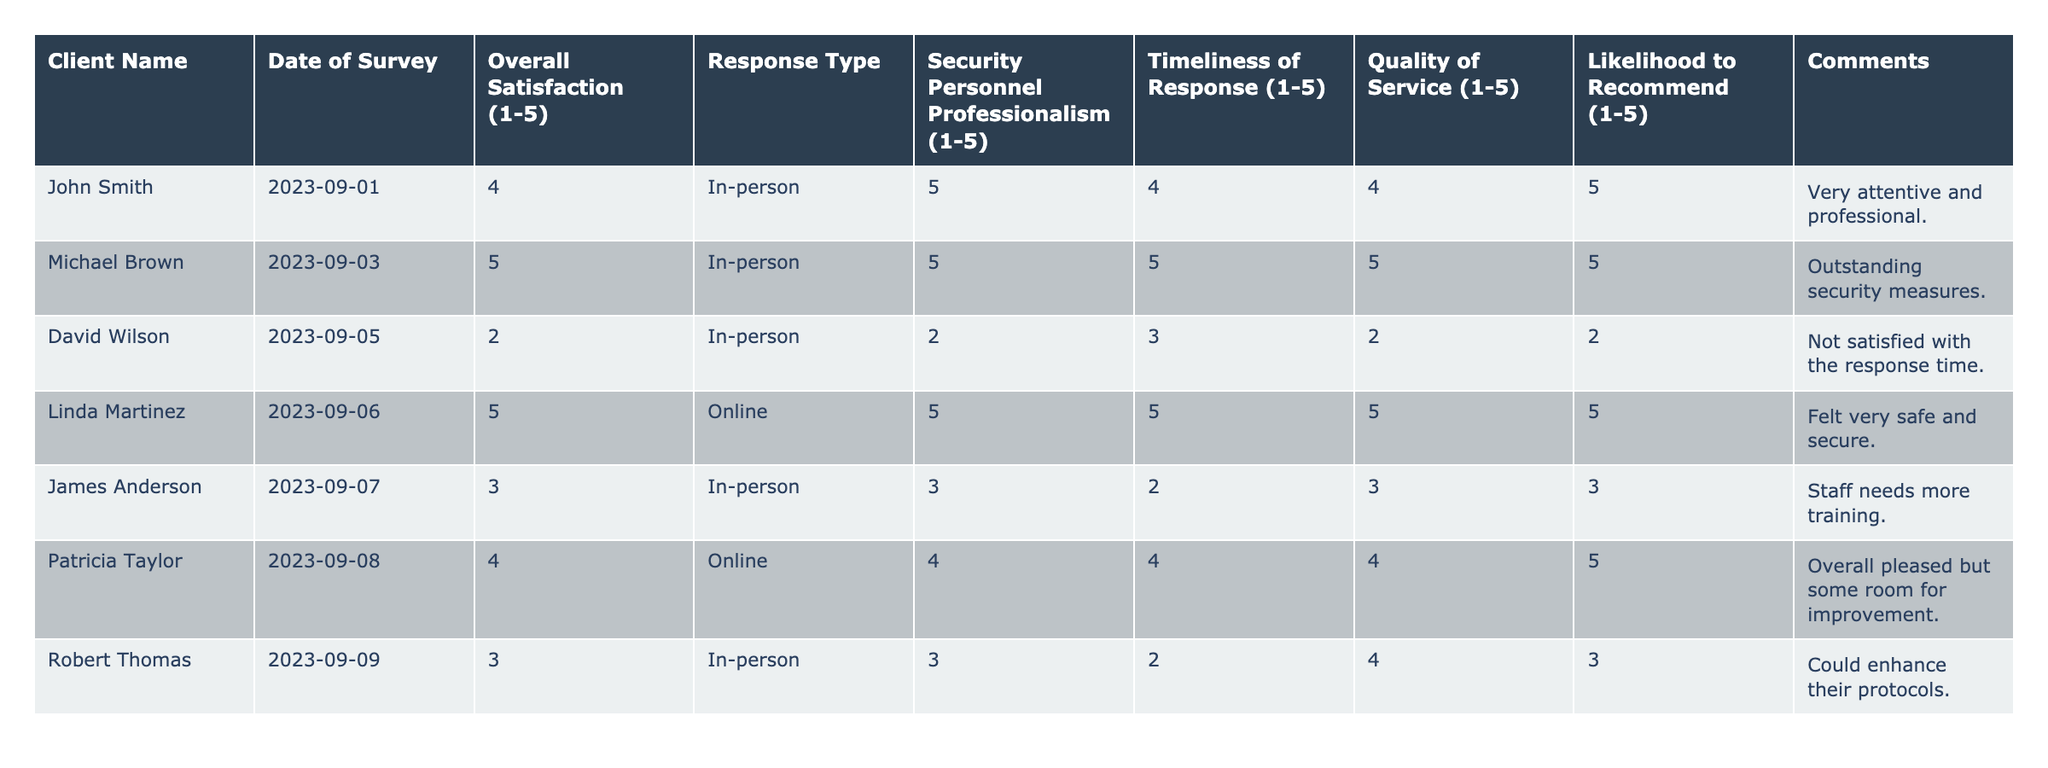What is the overall satisfaction rating of Linda Martinez? The table shows Linda Martinez's satisfaction rating which is clearly indicated in the "Overall Satisfaction (1-5)" column next to her name. Her rating is 5.
Answer: 5 How many clients gave a satisfaction rating of 3? By checking the "Overall Satisfaction (1-5)" column, I find that two clients, James Anderson and Robert Thomas, both rated their satisfaction as 3.
Answer: 2 What was the highest score given for the "Security Personnel Professionalism"? The "Security Personnel Professionalism (1-5)" column has values, with the highest score being 5, given by both Michael Brown and Linda Martinez.
Answer: 5 What is the average "Timeliness of Response" rating across all clients? I sum the values in the "Timeliness of Response (1-5)" column: (4 + 5 + 3 + 5 + 2 + 4 + 2) = 25. There are 7 clients, so the average is 25 / 7 ≈ 3.57.
Answer: 3.57 Is there any client who rated "Quality of Service" as 2? I check the "Quality of Service (1-5)" column and see that David Wilson rated it as 2.
Answer: Yes What is the overall satisfaction rating for clients who participated in the survey online? Looking at the "Overall Satisfaction (1-5)" ratings for the online responses (Linda Martinez and Patricia Taylor), I find values of 5 and 4. The average is (5 + 4) / 2 = 4.5.
Answer: 4.5 Did any client express satisfaction with the professionalism of security personnel while also rating overall satisfaction as less than 3? By reviewing the "Security Personnel Professionalism (1-5)" and "Overall Satisfaction (1-5)" ratings, David Wilson rated professionalism as 2 and overall satisfaction as 2, so he did express this opinion.
Answer: Yes What can be inferred about the likelihood to recommend security services from David Wilson's feedback? David Wilson rated the "Likelihood to Recommend (1-5)" as 2, indicating a low likelihood to recommend the services based on his dissatisfaction.
Answer: Low likelihood How many clients are likely to recommend the security services with a rating of 5? Checking the "Likelihood to Recommend (1-5)" column, I find that both Michael Brown and Linda Martinez rated it as 5, totaling 2 clients.
Answer: 2 What was the main concern expressed by David Wilson in his comments? His comment states dissatisfaction with the response time, reflecting his concern regarding the efficiency of security services.
Answer: Dissatisfaction with response time 